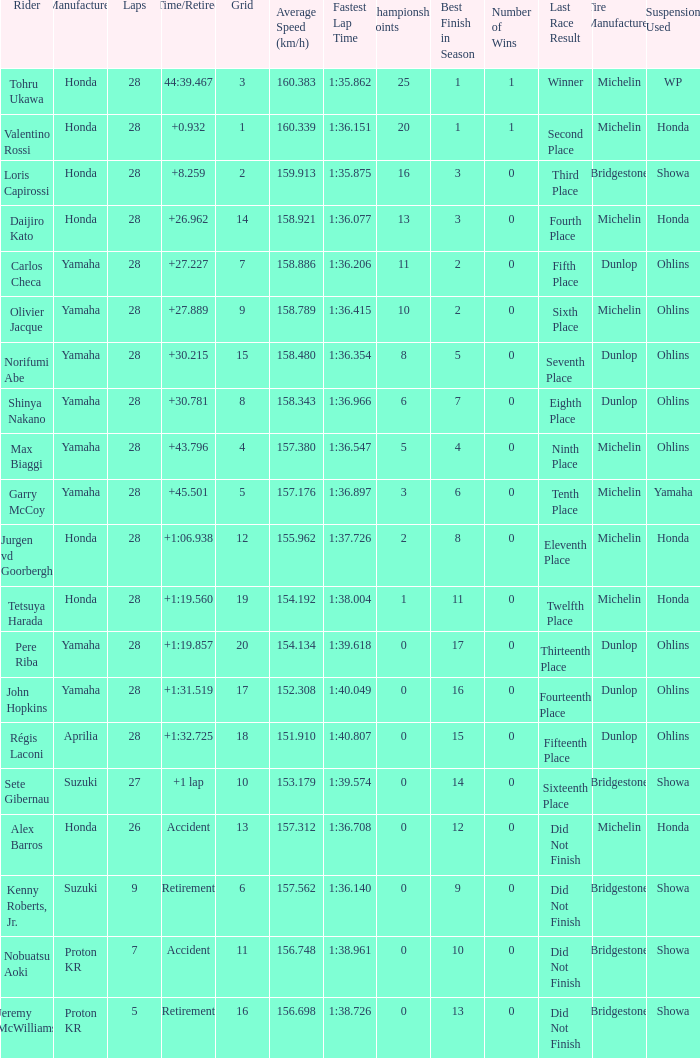Which grid contains laps more than 26, and a time/retired duration of 44:3 3.0. 